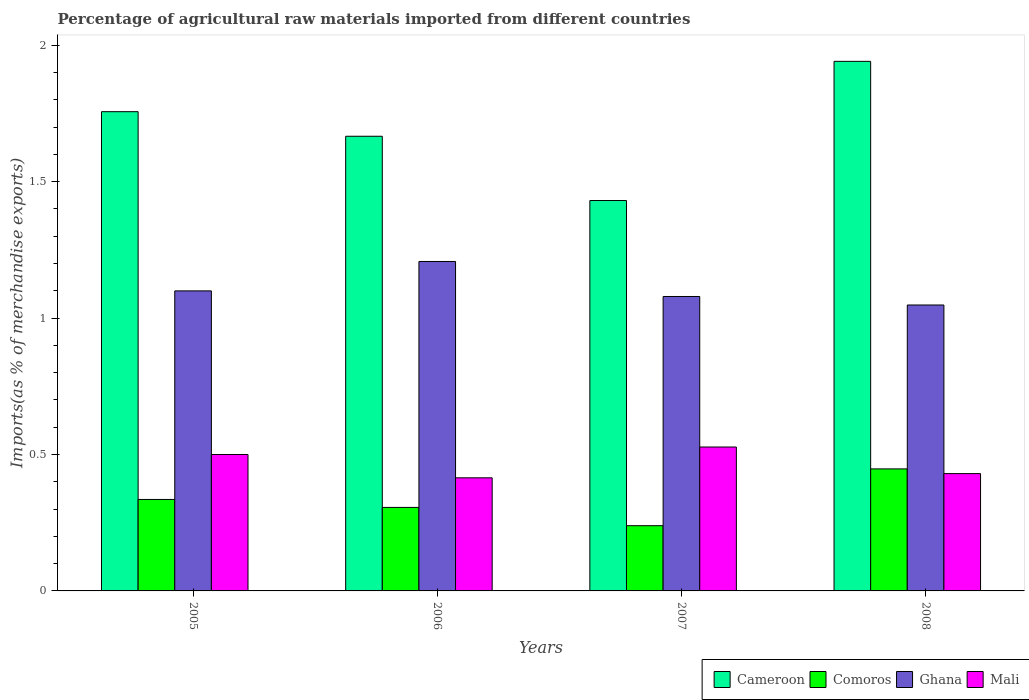How many different coloured bars are there?
Your answer should be compact. 4. Are the number of bars per tick equal to the number of legend labels?
Your answer should be very brief. Yes. Are the number of bars on each tick of the X-axis equal?
Your answer should be very brief. Yes. In how many cases, is the number of bars for a given year not equal to the number of legend labels?
Offer a terse response. 0. What is the percentage of imports to different countries in Cameroon in 2005?
Your answer should be very brief. 1.76. Across all years, what is the maximum percentage of imports to different countries in Ghana?
Your answer should be very brief. 1.21. Across all years, what is the minimum percentage of imports to different countries in Cameroon?
Your answer should be compact. 1.43. What is the total percentage of imports to different countries in Cameroon in the graph?
Your answer should be compact. 6.79. What is the difference between the percentage of imports to different countries in Mali in 2006 and that in 2007?
Give a very brief answer. -0.11. What is the difference between the percentage of imports to different countries in Cameroon in 2008 and the percentage of imports to different countries in Ghana in 2006?
Give a very brief answer. 0.73. What is the average percentage of imports to different countries in Cameroon per year?
Offer a terse response. 1.7. In the year 2008, what is the difference between the percentage of imports to different countries in Mali and percentage of imports to different countries in Ghana?
Offer a very short reply. -0.62. What is the ratio of the percentage of imports to different countries in Cameroon in 2005 to that in 2008?
Your response must be concise. 0.9. Is the percentage of imports to different countries in Comoros in 2005 less than that in 2006?
Offer a terse response. No. Is the difference between the percentage of imports to different countries in Mali in 2005 and 2006 greater than the difference between the percentage of imports to different countries in Ghana in 2005 and 2006?
Give a very brief answer. Yes. What is the difference between the highest and the second highest percentage of imports to different countries in Cameroon?
Provide a succinct answer. 0.18. What is the difference between the highest and the lowest percentage of imports to different countries in Cameroon?
Keep it short and to the point. 0.51. In how many years, is the percentage of imports to different countries in Comoros greater than the average percentage of imports to different countries in Comoros taken over all years?
Your response must be concise. 2. What does the 2nd bar from the left in 2005 represents?
Your answer should be very brief. Comoros. What does the 3rd bar from the right in 2007 represents?
Make the answer very short. Comoros. How many bars are there?
Offer a terse response. 16. Are all the bars in the graph horizontal?
Your answer should be very brief. No. Does the graph contain any zero values?
Your answer should be very brief. No. Does the graph contain grids?
Give a very brief answer. No. Where does the legend appear in the graph?
Provide a succinct answer. Bottom right. What is the title of the graph?
Your response must be concise. Percentage of agricultural raw materials imported from different countries. What is the label or title of the Y-axis?
Your answer should be very brief. Imports(as % of merchandise exports). What is the Imports(as % of merchandise exports) in Cameroon in 2005?
Provide a succinct answer. 1.76. What is the Imports(as % of merchandise exports) of Comoros in 2005?
Keep it short and to the point. 0.34. What is the Imports(as % of merchandise exports) in Ghana in 2005?
Offer a terse response. 1.1. What is the Imports(as % of merchandise exports) in Mali in 2005?
Ensure brevity in your answer.  0.5. What is the Imports(as % of merchandise exports) in Cameroon in 2006?
Provide a succinct answer. 1.67. What is the Imports(as % of merchandise exports) in Comoros in 2006?
Ensure brevity in your answer.  0.31. What is the Imports(as % of merchandise exports) of Ghana in 2006?
Give a very brief answer. 1.21. What is the Imports(as % of merchandise exports) of Mali in 2006?
Provide a succinct answer. 0.41. What is the Imports(as % of merchandise exports) of Cameroon in 2007?
Your answer should be very brief. 1.43. What is the Imports(as % of merchandise exports) of Comoros in 2007?
Offer a terse response. 0.24. What is the Imports(as % of merchandise exports) in Ghana in 2007?
Make the answer very short. 1.08. What is the Imports(as % of merchandise exports) of Mali in 2007?
Provide a short and direct response. 0.53. What is the Imports(as % of merchandise exports) in Cameroon in 2008?
Give a very brief answer. 1.94. What is the Imports(as % of merchandise exports) in Comoros in 2008?
Your response must be concise. 0.45. What is the Imports(as % of merchandise exports) of Ghana in 2008?
Your answer should be compact. 1.05. What is the Imports(as % of merchandise exports) of Mali in 2008?
Offer a terse response. 0.43. Across all years, what is the maximum Imports(as % of merchandise exports) of Cameroon?
Your answer should be very brief. 1.94. Across all years, what is the maximum Imports(as % of merchandise exports) in Comoros?
Offer a very short reply. 0.45. Across all years, what is the maximum Imports(as % of merchandise exports) in Ghana?
Your answer should be very brief. 1.21. Across all years, what is the maximum Imports(as % of merchandise exports) in Mali?
Offer a terse response. 0.53. Across all years, what is the minimum Imports(as % of merchandise exports) of Cameroon?
Provide a short and direct response. 1.43. Across all years, what is the minimum Imports(as % of merchandise exports) of Comoros?
Ensure brevity in your answer.  0.24. Across all years, what is the minimum Imports(as % of merchandise exports) of Ghana?
Provide a short and direct response. 1.05. Across all years, what is the minimum Imports(as % of merchandise exports) of Mali?
Provide a succinct answer. 0.41. What is the total Imports(as % of merchandise exports) of Cameroon in the graph?
Give a very brief answer. 6.79. What is the total Imports(as % of merchandise exports) in Comoros in the graph?
Provide a short and direct response. 1.33. What is the total Imports(as % of merchandise exports) of Ghana in the graph?
Make the answer very short. 4.43. What is the total Imports(as % of merchandise exports) in Mali in the graph?
Provide a succinct answer. 1.87. What is the difference between the Imports(as % of merchandise exports) of Cameroon in 2005 and that in 2006?
Your answer should be compact. 0.09. What is the difference between the Imports(as % of merchandise exports) of Comoros in 2005 and that in 2006?
Provide a succinct answer. 0.03. What is the difference between the Imports(as % of merchandise exports) of Ghana in 2005 and that in 2006?
Make the answer very short. -0.11. What is the difference between the Imports(as % of merchandise exports) of Mali in 2005 and that in 2006?
Make the answer very short. 0.09. What is the difference between the Imports(as % of merchandise exports) in Cameroon in 2005 and that in 2007?
Provide a succinct answer. 0.33. What is the difference between the Imports(as % of merchandise exports) of Comoros in 2005 and that in 2007?
Offer a terse response. 0.1. What is the difference between the Imports(as % of merchandise exports) of Ghana in 2005 and that in 2007?
Your response must be concise. 0.02. What is the difference between the Imports(as % of merchandise exports) of Mali in 2005 and that in 2007?
Provide a short and direct response. -0.03. What is the difference between the Imports(as % of merchandise exports) of Cameroon in 2005 and that in 2008?
Ensure brevity in your answer.  -0.18. What is the difference between the Imports(as % of merchandise exports) of Comoros in 2005 and that in 2008?
Provide a succinct answer. -0.11. What is the difference between the Imports(as % of merchandise exports) of Ghana in 2005 and that in 2008?
Your answer should be very brief. 0.05. What is the difference between the Imports(as % of merchandise exports) in Mali in 2005 and that in 2008?
Keep it short and to the point. 0.07. What is the difference between the Imports(as % of merchandise exports) in Cameroon in 2006 and that in 2007?
Give a very brief answer. 0.24. What is the difference between the Imports(as % of merchandise exports) of Comoros in 2006 and that in 2007?
Provide a short and direct response. 0.07. What is the difference between the Imports(as % of merchandise exports) of Ghana in 2006 and that in 2007?
Ensure brevity in your answer.  0.13. What is the difference between the Imports(as % of merchandise exports) in Mali in 2006 and that in 2007?
Provide a short and direct response. -0.11. What is the difference between the Imports(as % of merchandise exports) in Cameroon in 2006 and that in 2008?
Provide a short and direct response. -0.27. What is the difference between the Imports(as % of merchandise exports) in Comoros in 2006 and that in 2008?
Your answer should be very brief. -0.14. What is the difference between the Imports(as % of merchandise exports) of Ghana in 2006 and that in 2008?
Offer a very short reply. 0.16. What is the difference between the Imports(as % of merchandise exports) of Mali in 2006 and that in 2008?
Give a very brief answer. -0.02. What is the difference between the Imports(as % of merchandise exports) of Cameroon in 2007 and that in 2008?
Offer a terse response. -0.51. What is the difference between the Imports(as % of merchandise exports) of Comoros in 2007 and that in 2008?
Your answer should be compact. -0.21. What is the difference between the Imports(as % of merchandise exports) of Ghana in 2007 and that in 2008?
Keep it short and to the point. 0.03. What is the difference between the Imports(as % of merchandise exports) of Mali in 2007 and that in 2008?
Provide a short and direct response. 0.1. What is the difference between the Imports(as % of merchandise exports) of Cameroon in 2005 and the Imports(as % of merchandise exports) of Comoros in 2006?
Make the answer very short. 1.45. What is the difference between the Imports(as % of merchandise exports) of Cameroon in 2005 and the Imports(as % of merchandise exports) of Ghana in 2006?
Keep it short and to the point. 0.55. What is the difference between the Imports(as % of merchandise exports) of Cameroon in 2005 and the Imports(as % of merchandise exports) of Mali in 2006?
Offer a very short reply. 1.34. What is the difference between the Imports(as % of merchandise exports) in Comoros in 2005 and the Imports(as % of merchandise exports) in Ghana in 2006?
Make the answer very short. -0.87. What is the difference between the Imports(as % of merchandise exports) in Comoros in 2005 and the Imports(as % of merchandise exports) in Mali in 2006?
Provide a short and direct response. -0.08. What is the difference between the Imports(as % of merchandise exports) of Ghana in 2005 and the Imports(as % of merchandise exports) of Mali in 2006?
Your answer should be very brief. 0.69. What is the difference between the Imports(as % of merchandise exports) of Cameroon in 2005 and the Imports(as % of merchandise exports) of Comoros in 2007?
Provide a succinct answer. 1.52. What is the difference between the Imports(as % of merchandise exports) of Cameroon in 2005 and the Imports(as % of merchandise exports) of Ghana in 2007?
Your answer should be very brief. 0.68. What is the difference between the Imports(as % of merchandise exports) in Cameroon in 2005 and the Imports(as % of merchandise exports) in Mali in 2007?
Keep it short and to the point. 1.23. What is the difference between the Imports(as % of merchandise exports) in Comoros in 2005 and the Imports(as % of merchandise exports) in Ghana in 2007?
Your response must be concise. -0.74. What is the difference between the Imports(as % of merchandise exports) in Comoros in 2005 and the Imports(as % of merchandise exports) in Mali in 2007?
Your answer should be compact. -0.19. What is the difference between the Imports(as % of merchandise exports) of Ghana in 2005 and the Imports(as % of merchandise exports) of Mali in 2007?
Give a very brief answer. 0.57. What is the difference between the Imports(as % of merchandise exports) of Cameroon in 2005 and the Imports(as % of merchandise exports) of Comoros in 2008?
Give a very brief answer. 1.31. What is the difference between the Imports(as % of merchandise exports) in Cameroon in 2005 and the Imports(as % of merchandise exports) in Ghana in 2008?
Give a very brief answer. 0.71. What is the difference between the Imports(as % of merchandise exports) of Cameroon in 2005 and the Imports(as % of merchandise exports) of Mali in 2008?
Make the answer very short. 1.33. What is the difference between the Imports(as % of merchandise exports) in Comoros in 2005 and the Imports(as % of merchandise exports) in Ghana in 2008?
Your response must be concise. -0.71. What is the difference between the Imports(as % of merchandise exports) in Comoros in 2005 and the Imports(as % of merchandise exports) in Mali in 2008?
Provide a short and direct response. -0.09. What is the difference between the Imports(as % of merchandise exports) of Ghana in 2005 and the Imports(as % of merchandise exports) of Mali in 2008?
Your answer should be compact. 0.67. What is the difference between the Imports(as % of merchandise exports) of Cameroon in 2006 and the Imports(as % of merchandise exports) of Comoros in 2007?
Provide a short and direct response. 1.43. What is the difference between the Imports(as % of merchandise exports) of Cameroon in 2006 and the Imports(as % of merchandise exports) of Ghana in 2007?
Give a very brief answer. 0.59. What is the difference between the Imports(as % of merchandise exports) of Cameroon in 2006 and the Imports(as % of merchandise exports) of Mali in 2007?
Offer a terse response. 1.14. What is the difference between the Imports(as % of merchandise exports) of Comoros in 2006 and the Imports(as % of merchandise exports) of Ghana in 2007?
Provide a succinct answer. -0.77. What is the difference between the Imports(as % of merchandise exports) of Comoros in 2006 and the Imports(as % of merchandise exports) of Mali in 2007?
Your response must be concise. -0.22. What is the difference between the Imports(as % of merchandise exports) of Ghana in 2006 and the Imports(as % of merchandise exports) of Mali in 2007?
Offer a terse response. 0.68. What is the difference between the Imports(as % of merchandise exports) in Cameroon in 2006 and the Imports(as % of merchandise exports) in Comoros in 2008?
Keep it short and to the point. 1.22. What is the difference between the Imports(as % of merchandise exports) in Cameroon in 2006 and the Imports(as % of merchandise exports) in Ghana in 2008?
Make the answer very short. 0.62. What is the difference between the Imports(as % of merchandise exports) in Cameroon in 2006 and the Imports(as % of merchandise exports) in Mali in 2008?
Your answer should be compact. 1.24. What is the difference between the Imports(as % of merchandise exports) in Comoros in 2006 and the Imports(as % of merchandise exports) in Ghana in 2008?
Ensure brevity in your answer.  -0.74. What is the difference between the Imports(as % of merchandise exports) of Comoros in 2006 and the Imports(as % of merchandise exports) of Mali in 2008?
Offer a very short reply. -0.12. What is the difference between the Imports(as % of merchandise exports) of Ghana in 2006 and the Imports(as % of merchandise exports) of Mali in 2008?
Your response must be concise. 0.78. What is the difference between the Imports(as % of merchandise exports) of Cameroon in 2007 and the Imports(as % of merchandise exports) of Comoros in 2008?
Your answer should be very brief. 0.98. What is the difference between the Imports(as % of merchandise exports) of Cameroon in 2007 and the Imports(as % of merchandise exports) of Ghana in 2008?
Offer a very short reply. 0.38. What is the difference between the Imports(as % of merchandise exports) in Comoros in 2007 and the Imports(as % of merchandise exports) in Ghana in 2008?
Your answer should be very brief. -0.81. What is the difference between the Imports(as % of merchandise exports) of Comoros in 2007 and the Imports(as % of merchandise exports) of Mali in 2008?
Your answer should be compact. -0.19. What is the difference between the Imports(as % of merchandise exports) in Ghana in 2007 and the Imports(as % of merchandise exports) in Mali in 2008?
Provide a short and direct response. 0.65. What is the average Imports(as % of merchandise exports) in Cameroon per year?
Keep it short and to the point. 1.7. What is the average Imports(as % of merchandise exports) of Comoros per year?
Offer a very short reply. 0.33. What is the average Imports(as % of merchandise exports) of Ghana per year?
Make the answer very short. 1.11. What is the average Imports(as % of merchandise exports) in Mali per year?
Make the answer very short. 0.47. In the year 2005, what is the difference between the Imports(as % of merchandise exports) of Cameroon and Imports(as % of merchandise exports) of Comoros?
Give a very brief answer. 1.42. In the year 2005, what is the difference between the Imports(as % of merchandise exports) in Cameroon and Imports(as % of merchandise exports) in Ghana?
Make the answer very short. 0.66. In the year 2005, what is the difference between the Imports(as % of merchandise exports) in Cameroon and Imports(as % of merchandise exports) in Mali?
Give a very brief answer. 1.26. In the year 2005, what is the difference between the Imports(as % of merchandise exports) in Comoros and Imports(as % of merchandise exports) in Ghana?
Give a very brief answer. -0.76. In the year 2005, what is the difference between the Imports(as % of merchandise exports) of Comoros and Imports(as % of merchandise exports) of Mali?
Provide a succinct answer. -0.16. In the year 2005, what is the difference between the Imports(as % of merchandise exports) in Ghana and Imports(as % of merchandise exports) in Mali?
Ensure brevity in your answer.  0.6. In the year 2006, what is the difference between the Imports(as % of merchandise exports) of Cameroon and Imports(as % of merchandise exports) of Comoros?
Keep it short and to the point. 1.36. In the year 2006, what is the difference between the Imports(as % of merchandise exports) of Cameroon and Imports(as % of merchandise exports) of Ghana?
Give a very brief answer. 0.46. In the year 2006, what is the difference between the Imports(as % of merchandise exports) in Cameroon and Imports(as % of merchandise exports) in Mali?
Provide a succinct answer. 1.25. In the year 2006, what is the difference between the Imports(as % of merchandise exports) in Comoros and Imports(as % of merchandise exports) in Ghana?
Your answer should be compact. -0.9. In the year 2006, what is the difference between the Imports(as % of merchandise exports) of Comoros and Imports(as % of merchandise exports) of Mali?
Keep it short and to the point. -0.11. In the year 2006, what is the difference between the Imports(as % of merchandise exports) of Ghana and Imports(as % of merchandise exports) of Mali?
Offer a very short reply. 0.79. In the year 2007, what is the difference between the Imports(as % of merchandise exports) of Cameroon and Imports(as % of merchandise exports) of Comoros?
Give a very brief answer. 1.19. In the year 2007, what is the difference between the Imports(as % of merchandise exports) in Cameroon and Imports(as % of merchandise exports) in Ghana?
Provide a succinct answer. 0.35. In the year 2007, what is the difference between the Imports(as % of merchandise exports) of Cameroon and Imports(as % of merchandise exports) of Mali?
Your response must be concise. 0.9. In the year 2007, what is the difference between the Imports(as % of merchandise exports) of Comoros and Imports(as % of merchandise exports) of Ghana?
Give a very brief answer. -0.84. In the year 2007, what is the difference between the Imports(as % of merchandise exports) in Comoros and Imports(as % of merchandise exports) in Mali?
Ensure brevity in your answer.  -0.29. In the year 2007, what is the difference between the Imports(as % of merchandise exports) of Ghana and Imports(as % of merchandise exports) of Mali?
Provide a short and direct response. 0.55. In the year 2008, what is the difference between the Imports(as % of merchandise exports) in Cameroon and Imports(as % of merchandise exports) in Comoros?
Provide a short and direct response. 1.49. In the year 2008, what is the difference between the Imports(as % of merchandise exports) in Cameroon and Imports(as % of merchandise exports) in Ghana?
Your response must be concise. 0.89. In the year 2008, what is the difference between the Imports(as % of merchandise exports) of Cameroon and Imports(as % of merchandise exports) of Mali?
Your response must be concise. 1.51. In the year 2008, what is the difference between the Imports(as % of merchandise exports) in Comoros and Imports(as % of merchandise exports) in Ghana?
Provide a short and direct response. -0.6. In the year 2008, what is the difference between the Imports(as % of merchandise exports) in Comoros and Imports(as % of merchandise exports) in Mali?
Ensure brevity in your answer.  0.02. In the year 2008, what is the difference between the Imports(as % of merchandise exports) of Ghana and Imports(as % of merchandise exports) of Mali?
Make the answer very short. 0.62. What is the ratio of the Imports(as % of merchandise exports) of Cameroon in 2005 to that in 2006?
Provide a succinct answer. 1.05. What is the ratio of the Imports(as % of merchandise exports) of Comoros in 2005 to that in 2006?
Keep it short and to the point. 1.1. What is the ratio of the Imports(as % of merchandise exports) of Ghana in 2005 to that in 2006?
Your response must be concise. 0.91. What is the ratio of the Imports(as % of merchandise exports) of Mali in 2005 to that in 2006?
Offer a very short reply. 1.21. What is the ratio of the Imports(as % of merchandise exports) in Cameroon in 2005 to that in 2007?
Your answer should be very brief. 1.23. What is the ratio of the Imports(as % of merchandise exports) in Comoros in 2005 to that in 2007?
Offer a very short reply. 1.4. What is the ratio of the Imports(as % of merchandise exports) of Mali in 2005 to that in 2007?
Your answer should be very brief. 0.95. What is the ratio of the Imports(as % of merchandise exports) of Cameroon in 2005 to that in 2008?
Offer a terse response. 0.91. What is the ratio of the Imports(as % of merchandise exports) of Comoros in 2005 to that in 2008?
Your answer should be compact. 0.75. What is the ratio of the Imports(as % of merchandise exports) in Ghana in 2005 to that in 2008?
Offer a very short reply. 1.05. What is the ratio of the Imports(as % of merchandise exports) in Mali in 2005 to that in 2008?
Your response must be concise. 1.16. What is the ratio of the Imports(as % of merchandise exports) in Cameroon in 2006 to that in 2007?
Make the answer very short. 1.16. What is the ratio of the Imports(as % of merchandise exports) in Comoros in 2006 to that in 2007?
Provide a succinct answer. 1.28. What is the ratio of the Imports(as % of merchandise exports) of Ghana in 2006 to that in 2007?
Offer a very short reply. 1.12. What is the ratio of the Imports(as % of merchandise exports) of Mali in 2006 to that in 2007?
Provide a short and direct response. 0.79. What is the ratio of the Imports(as % of merchandise exports) in Cameroon in 2006 to that in 2008?
Give a very brief answer. 0.86. What is the ratio of the Imports(as % of merchandise exports) in Comoros in 2006 to that in 2008?
Provide a succinct answer. 0.68. What is the ratio of the Imports(as % of merchandise exports) in Ghana in 2006 to that in 2008?
Provide a short and direct response. 1.15. What is the ratio of the Imports(as % of merchandise exports) in Cameroon in 2007 to that in 2008?
Offer a very short reply. 0.74. What is the ratio of the Imports(as % of merchandise exports) of Comoros in 2007 to that in 2008?
Offer a very short reply. 0.53. What is the ratio of the Imports(as % of merchandise exports) of Ghana in 2007 to that in 2008?
Your response must be concise. 1.03. What is the ratio of the Imports(as % of merchandise exports) of Mali in 2007 to that in 2008?
Offer a terse response. 1.23. What is the difference between the highest and the second highest Imports(as % of merchandise exports) in Cameroon?
Make the answer very short. 0.18. What is the difference between the highest and the second highest Imports(as % of merchandise exports) of Comoros?
Make the answer very short. 0.11. What is the difference between the highest and the second highest Imports(as % of merchandise exports) in Ghana?
Keep it short and to the point. 0.11. What is the difference between the highest and the second highest Imports(as % of merchandise exports) of Mali?
Make the answer very short. 0.03. What is the difference between the highest and the lowest Imports(as % of merchandise exports) of Cameroon?
Give a very brief answer. 0.51. What is the difference between the highest and the lowest Imports(as % of merchandise exports) in Comoros?
Your answer should be very brief. 0.21. What is the difference between the highest and the lowest Imports(as % of merchandise exports) in Ghana?
Provide a short and direct response. 0.16. What is the difference between the highest and the lowest Imports(as % of merchandise exports) of Mali?
Provide a short and direct response. 0.11. 